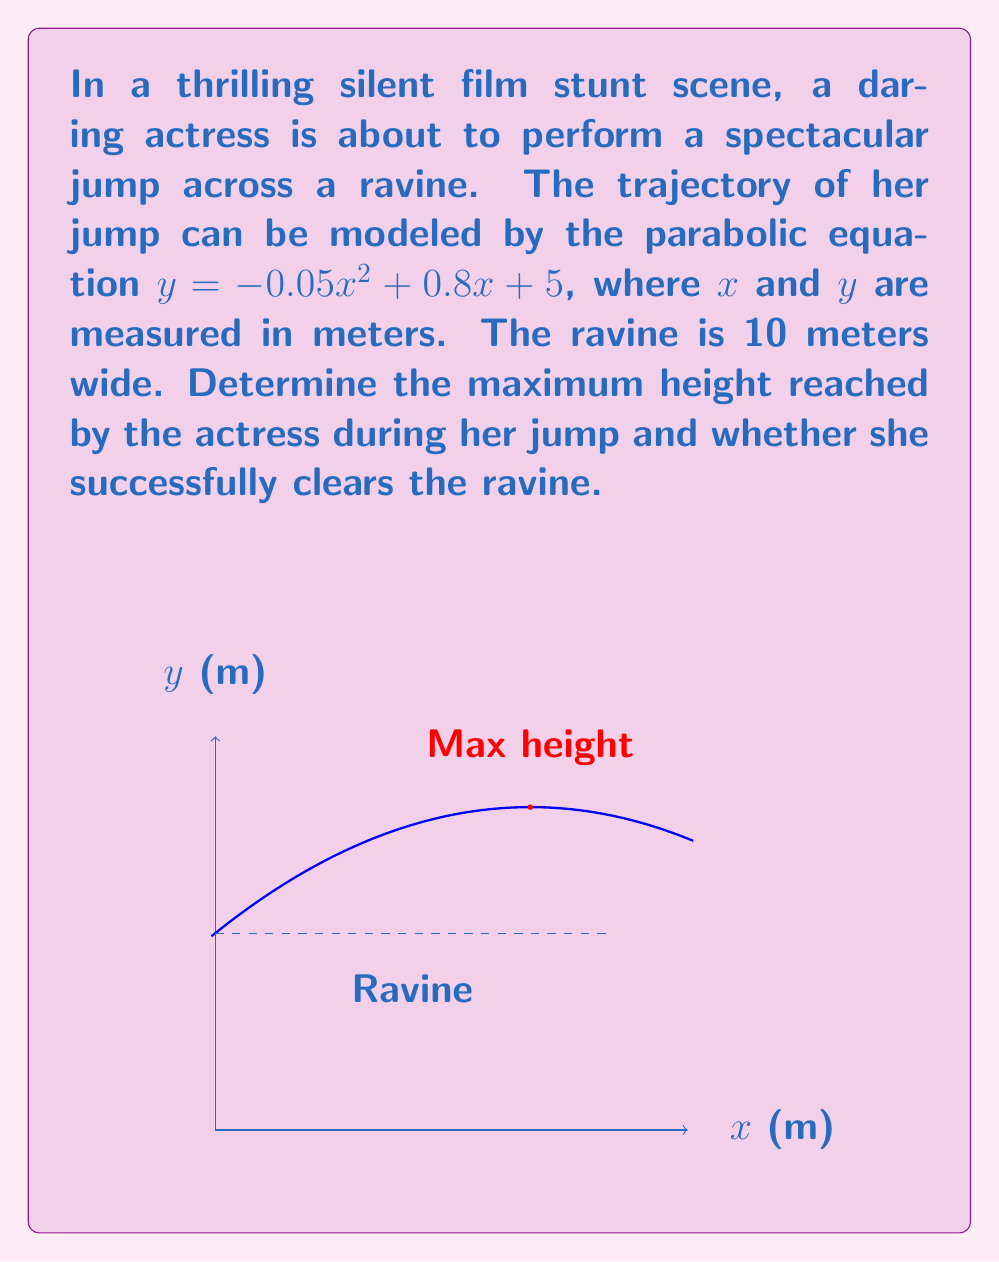Can you answer this question? Let's approach this step-by-step:

1) The parabolic equation is given as $y = -0.05x^2 + 0.8x + 5$

2) To find the maximum height, we need to find the vertex of the parabola. For a quadratic equation in the form $y = ax^2 + bx + c$, the x-coordinate of the vertex is given by $x = -\frac{b}{2a}$

3) In this case, $a = -0.05$ and $b = 0.8$
   
   $x = -\frac{0.8}{2(-0.05)} = 8$ meters

4) To find the y-coordinate (maximum height), we substitute this x-value back into the original equation:

   $y = -0.05(8)^2 + 0.8(8) + 5$
   $y = -0.05(64) + 6.4 + 5$
   $y = -3.2 + 6.4 + 5 = 8.2$ meters

5) To check if she clears the ravine, we need to find y when x = 10 (the width of the ravine):

   $y = -0.05(10)^2 + 0.8(10) + 5$
   $y = -5 + 8 + 5 = 8$ meters

6) Since y > 0 when x = 10, she successfully clears the ravine.
Answer: Maximum height: 8.2 m; Clears ravine: Yes 